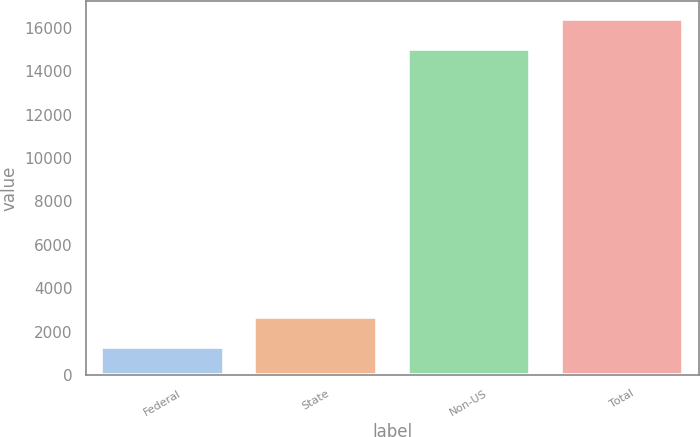Convert chart. <chart><loc_0><loc_0><loc_500><loc_500><bar_chart><fcel>Federal<fcel>State<fcel>Non-US<fcel>Total<nl><fcel>1292<fcel>2694.3<fcel>15025<fcel>16427.3<nl></chart> 